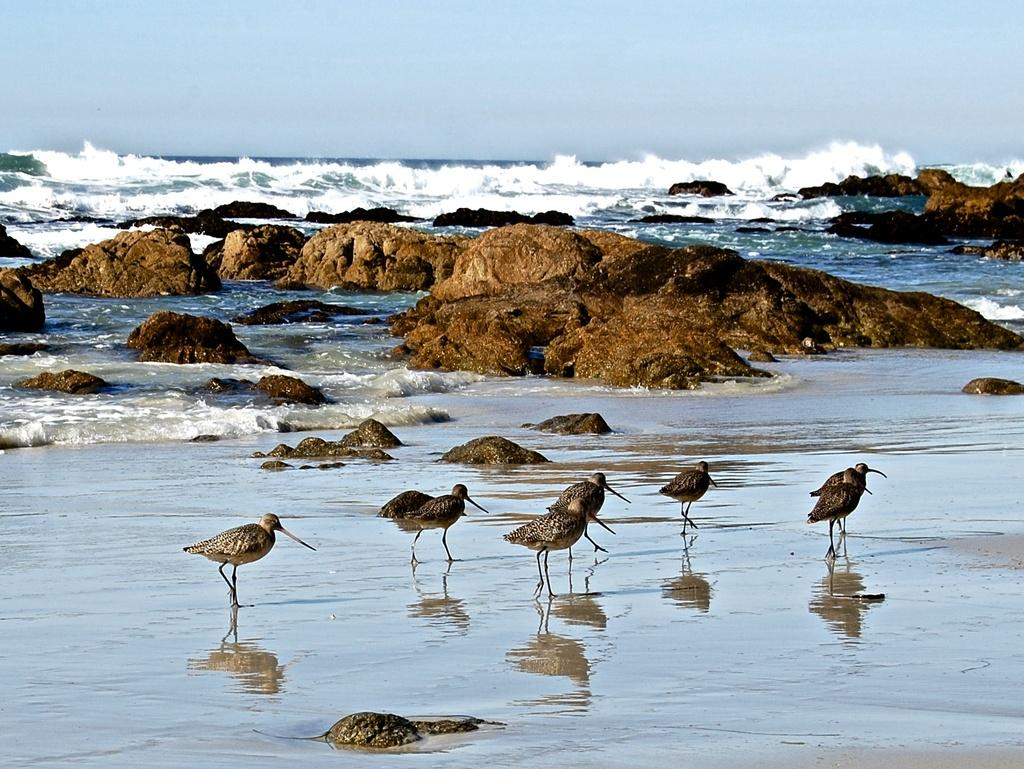What type of birds are in the image? There are dowitchers in the image. Where are the dowitchers located in the image? The dowitchers are on the shore. What can be seen in the background of the image? There is water visible in the image. What type of natural feature is present in the image? There are rocks in the image. What is the condition of the sky in the image? The sky is cloudy in the image. What type of clover can be seen growing near the dowitchers in the image? There is no clover present in the image. What type of weapon is visible in the image? There is no weapon present in the image. What type of military unit is visible in the image? There is no military unit present in the image. 